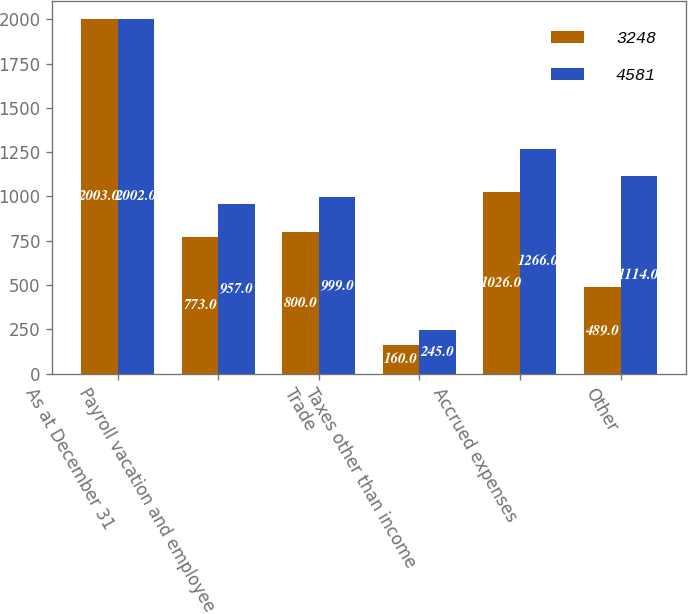<chart> <loc_0><loc_0><loc_500><loc_500><stacked_bar_chart><ecel><fcel>As at December 31<fcel>Payroll vacation and employee<fcel>Trade<fcel>Taxes other than income<fcel>Accrued expenses<fcel>Other<nl><fcel>3248<fcel>2003<fcel>773<fcel>800<fcel>160<fcel>1026<fcel>489<nl><fcel>4581<fcel>2002<fcel>957<fcel>999<fcel>245<fcel>1266<fcel>1114<nl></chart> 